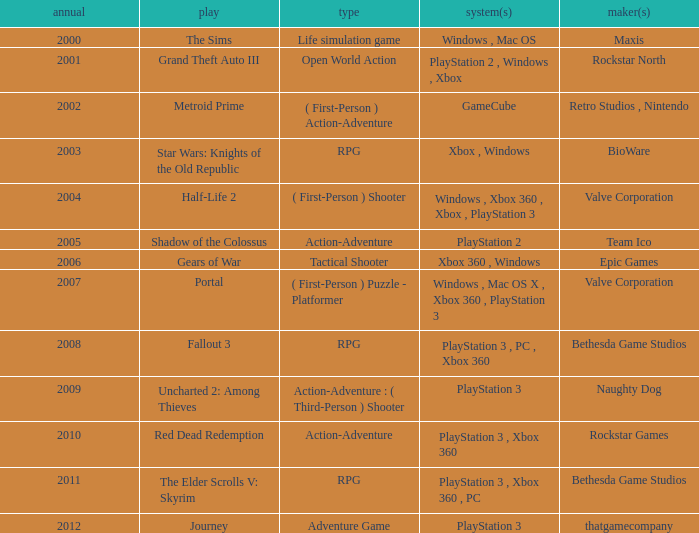What game was in 2001? Grand Theft Auto III. 